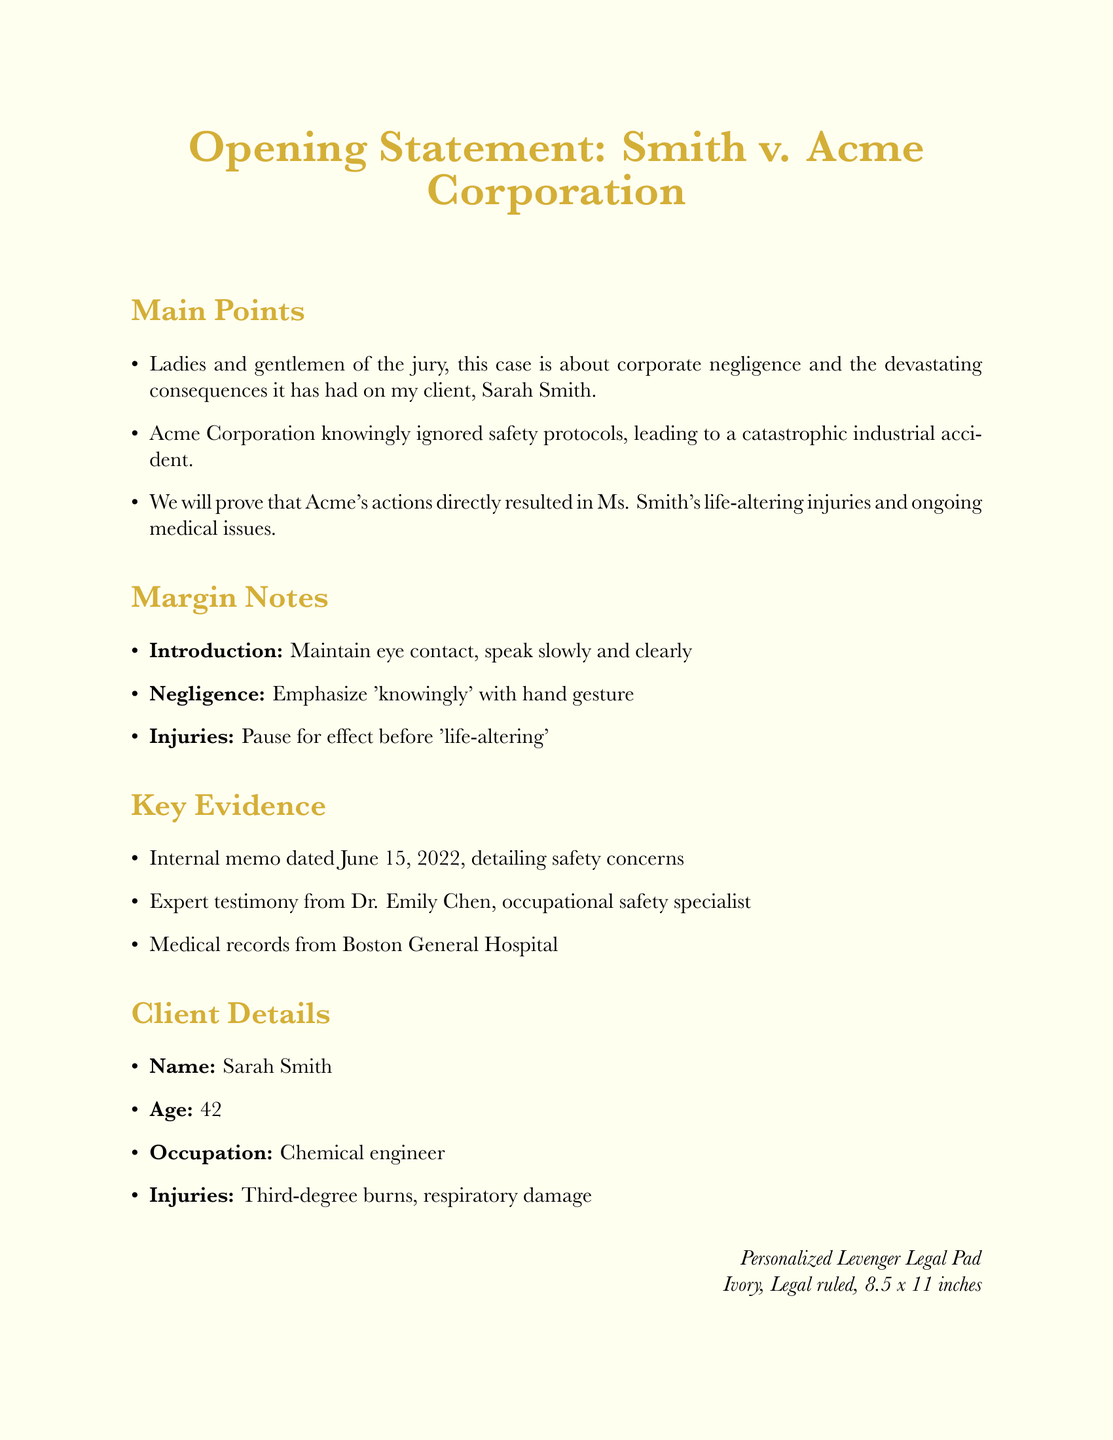What is the title of the document? The title is specified in the opening statement section, which is a central focus of the document.
Answer: Opening Statement: Smith v. Acme Corporation Who is the client in this case? The client's name is given directly in the client details section of the document.
Answer: Sarah Smith What is the age of the client? The age is stated in the client details section, providing specific information about the client.
Answer: 42 Which section contains information about margin notes? The margin notes are a specific section in the document that contain instructions for delivery and emphasis.
Answer: Margin Notes What key evidence is mentioned dated June 15, 2022? The document lists key evidence that includes dates; this specific date pertains to a memo highlighting safety concerns.
Answer: Internal memo dated June 15, 2022, detailing safety concerns What type of accident is described in the opening statement? The type of accident is mentioned in relation to the negligence of Acme Corporation, highlighting the consequences faced by the client.
Answer: catastrophic industrial accident How many main points are listed in the opening statement? The number of main points can be counted from the corresponding section, which outlines the central arguments.
Answer: 3 What are the listed injuries of the client? The injuries are specified directly in the client details section, providing crucial information for the case.
Answer: Third-degree burns, respiratory damage What are the specifications for the legal pad? The legal pad preferences describe brand, color, ruling, and size, detailing custom order preferences.
Answer: Levenger, Ivory, Legal ruled, 8.5 x 11 inches 